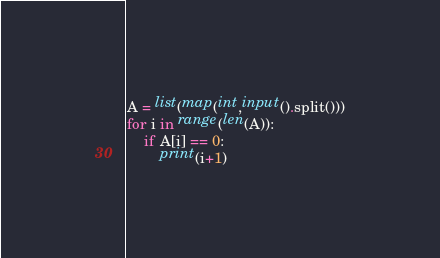Convert code to text. <code><loc_0><loc_0><loc_500><loc_500><_Python_>A = list(map(int,input().split()))
for i in range(len(A)):
    if A[i] == 0:
        print(i+1)</code> 